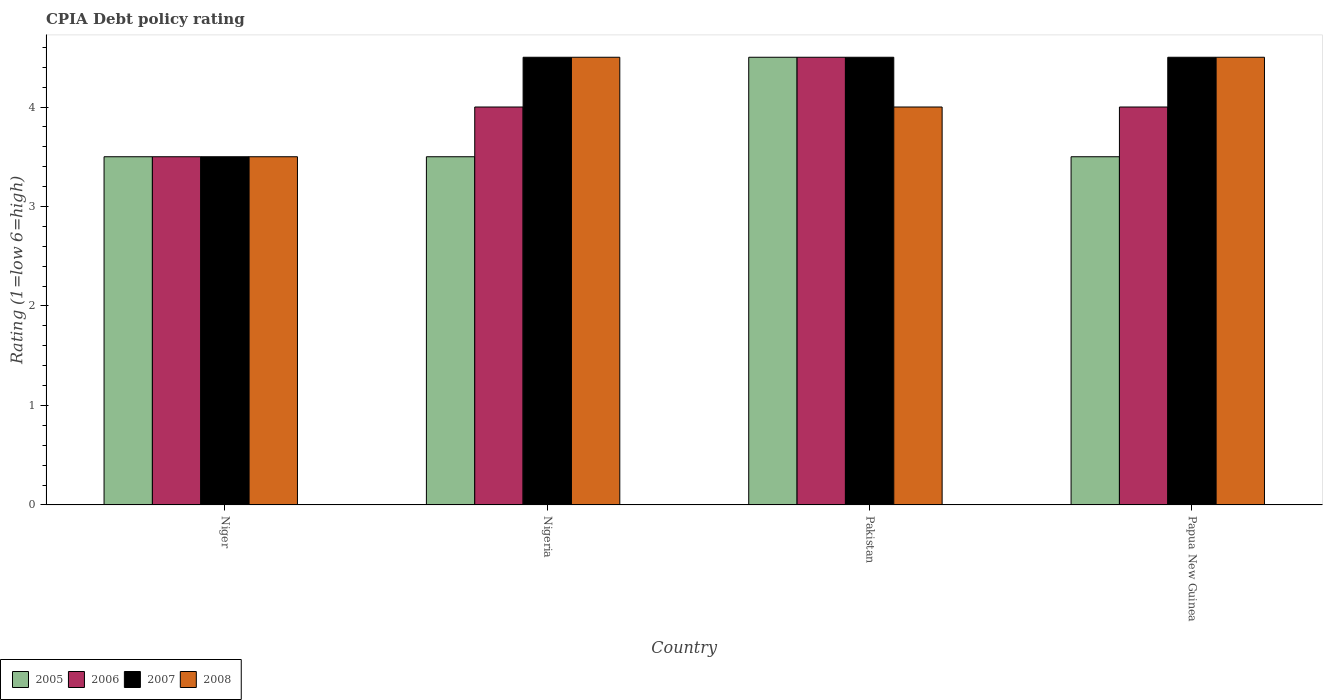How many different coloured bars are there?
Offer a terse response. 4. How many bars are there on the 1st tick from the left?
Ensure brevity in your answer.  4. What is the label of the 2nd group of bars from the left?
Offer a very short reply. Nigeria. Across all countries, what is the minimum CPIA rating in 2007?
Give a very brief answer. 3.5. In which country was the CPIA rating in 2008 maximum?
Your answer should be compact. Nigeria. In which country was the CPIA rating in 2008 minimum?
Your response must be concise. Niger. What is the total CPIA rating in 2006 in the graph?
Provide a short and direct response. 16. What is the difference between the CPIA rating of/in 2007 and CPIA rating of/in 2005 in Pakistan?
Your answer should be very brief. 0. In how many countries, is the CPIA rating in 2005 greater than 2.8?
Your response must be concise. 4. What is the ratio of the CPIA rating in 2005 in Nigeria to that in Pakistan?
Your answer should be compact. 0.78. What is the difference between the highest and the second highest CPIA rating in 2008?
Provide a short and direct response. 0.5. What is the difference between the highest and the lowest CPIA rating in 2005?
Keep it short and to the point. 1. Is the sum of the CPIA rating in 2005 in Niger and Papua New Guinea greater than the maximum CPIA rating in 2007 across all countries?
Your answer should be very brief. Yes. Is it the case that in every country, the sum of the CPIA rating in 2008 and CPIA rating in 2007 is greater than the sum of CPIA rating in 2005 and CPIA rating in 2006?
Keep it short and to the point. No. What does the 4th bar from the left in Nigeria represents?
Your answer should be very brief. 2008. How many bars are there?
Offer a terse response. 16. Are the values on the major ticks of Y-axis written in scientific E-notation?
Make the answer very short. No. Does the graph contain any zero values?
Your response must be concise. No. Does the graph contain grids?
Provide a short and direct response. No. How are the legend labels stacked?
Make the answer very short. Horizontal. What is the title of the graph?
Offer a terse response. CPIA Debt policy rating. Does "1970" appear as one of the legend labels in the graph?
Provide a short and direct response. No. What is the label or title of the X-axis?
Offer a very short reply. Country. What is the label or title of the Y-axis?
Offer a very short reply. Rating (1=low 6=high). What is the Rating (1=low 6=high) in 2005 in Niger?
Ensure brevity in your answer.  3.5. What is the Rating (1=low 6=high) of 2006 in Niger?
Your answer should be very brief. 3.5. What is the Rating (1=low 6=high) of 2005 in Nigeria?
Offer a very short reply. 3.5. What is the Rating (1=low 6=high) in 2006 in Nigeria?
Keep it short and to the point. 4. What is the Rating (1=low 6=high) in 2007 in Nigeria?
Your answer should be compact. 4.5. What is the Rating (1=low 6=high) of 2008 in Nigeria?
Your response must be concise. 4.5. What is the Rating (1=low 6=high) of 2006 in Pakistan?
Make the answer very short. 4.5. What is the Rating (1=low 6=high) in 2007 in Pakistan?
Make the answer very short. 4.5. What is the Rating (1=low 6=high) in 2005 in Papua New Guinea?
Your answer should be very brief. 3.5. What is the Rating (1=low 6=high) in 2007 in Papua New Guinea?
Give a very brief answer. 4.5. Across all countries, what is the minimum Rating (1=low 6=high) of 2007?
Ensure brevity in your answer.  3.5. Across all countries, what is the minimum Rating (1=low 6=high) of 2008?
Offer a terse response. 3.5. What is the total Rating (1=low 6=high) of 2005 in the graph?
Provide a succinct answer. 15. What is the total Rating (1=low 6=high) in 2006 in the graph?
Provide a short and direct response. 16. What is the difference between the Rating (1=low 6=high) in 2007 in Niger and that in Nigeria?
Your answer should be compact. -1. What is the difference between the Rating (1=low 6=high) in 2008 in Niger and that in Nigeria?
Make the answer very short. -1. What is the difference between the Rating (1=low 6=high) in 2006 in Niger and that in Pakistan?
Provide a short and direct response. -1. What is the difference between the Rating (1=low 6=high) of 2008 in Niger and that in Pakistan?
Provide a short and direct response. -0.5. What is the difference between the Rating (1=low 6=high) of 2006 in Niger and that in Papua New Guinea?
Offer a terse response. -0.5. What is the difference between the Rating (1=low 6=high) of 2007 in Niger and that in Papua New Guinea?
Your answer should be very brief. -1. What is the difference between the Rating (1=low 6=high) in 2005 in Nigeria and that in Pakistan?
Keep it short and to the point. -1. What is the difference between the Rating (1=low 6=high) in 2006 in Nigeria and that in Pakistan?
Make the answer very short. -0.5. What is the difference between the Rating (1=low 6=high) of 2007 in Nigeria and that in Pakistan?
Provide a succinct answer. 0. What is the difference between the Rating (1=low 6=high) of 2005 in Nigeria and that in Papua New Guinea?
Give a very brief answer. 0. What is the difference between the Rating (1=low 6=high) in 2006 in Nigeria and that in Papua New Guinea?
Ensure brevity in your answer.  0. What is the difference between the Rating (1=low 6=high) of 2005 in Pakistan and that in Papua New Guinea?
Provide a short and direct response. 1. What is the difference between the Rating (1=low 6=high) in 2006 in Pakistan and that in Papua New Guinea?
Your answer should be compact. 0.5. What is the difference between the Rating (1=low 6=high) in 2008 in Pakistan and that in Papua New Guinea?
Provide a succinct answer. -0.5. What is the difference between the Rating (1=low 6=high) of 2005 in Niger and the Rating (1=low 6=high) of 2008 in Nigeria?
Your response must be concise. -1. What is the difference between the Rating (1=low 6=high) of 2006 in Niger and the Rating (1=low 6=high) of 2007 in Nigeria?
Your response must be concise. -1. What is the difference between the Rating (1=low 6=high) of 2007 in Niger and the Rating (1=low 6=high) of 2008 in Nigeria?
Make the answer very short. -1. What is the difference between the Rating (1=low 6=high) of 2005 in Niger and the Rating (1=low 6=high) of 2006 in Pakistan?
Your response must be concise. -1. What is the difference between the Rating (1=low 6=high) in 2005 in Niger and the Rating (1=low 6=high) in 2008 in Pakistan?
Your answer should be compact. -0.5. What is the difference between the Rating (1=low 6=high) in 2006 in Niger and the Rating (1=low 6=high) in 2007 in Pakistan?
Your answer should be compact. -1. What is the difference between the Rating (1=low 6=high) in 2007 in Niger and the Rating (1=low 6=high) in 2008 in Pakistan?
Keep it short and to the point. -0.5. What is the difference between the Rating (1=low 6=high) in 2005 in Niger and the Rating (1=low 6=high) in 2007 in Papua New Guinea?
Your response must be concise. -1. What is the difference between the Rating (1=low 6=high) in 2005 in Niger and the Rating (1=low 6=high) in 2008 in Papua New Guinea?
Give a very brief answer. -1. What is the difference between the Rating (1=low 6=high) of 2006 in Niger and the Rating (1=low 6=high) of 2007 in Papua New Guinea?
Your answer should be very brief. -1. What is the difference between the Rating (1=low 6=high) in 2006 in Niger and the Rating (1=low 6=high) in 2008 in Papua New Guinea?
Offer a terse response. -1. What is the difference between the Rating (1=low 6=high) of 2005 in Nigeria and the Rating (1=low 6=high) of 2007 in Pakistan?
Offer a very short reply. -1. What is the difference between the Rating (1=low 6=high) in 2006 in Nigeria and the Rating (1=low 6=high) in 2008 in Pakistan?
Offer a very short reply. 0. What is the difference between the Rating (1=low 6=high) of 2007 in Nigeria and the Rating (1=low 6=high) of 2008 in Pakistan?
Your response must be concise. 0.5. What is the difference between the Rating (1=low 6=high) in 2005 in Nigeria and the Rating (1=low 6=high) in 2007 in Papua New Guinea?
Offer a terse response. -1. What is the difference between the Rating (1=low 6=high) of 2006 in Nigeria and the Rating (1=low 6=high) of 2007 in Papua New Guinea?
Give a very brief answer. -0.5. What is the difference between the Rating (1=low 6=high) in 2006 in Nigeria and the Rating (1=low 6=high) in 2008 in Papua New Guinea?
Make the answer very short. -0.5. What is the difference between the Rating (1=low 6=high) in 2007 in Nigeria and the Rating (1=low 6=high) in 2008 in Papua New Guinea?
Your response must be concise. 0. What is the difference between the Rating (1=low 6=high) of 2005 in Pakistan and the Rating (1=low 6=high) of 2007 in Papua New Guinea?
Your answer should be very brief. 0. What is the difference between the Rating (1=low 6=high) in 2005 in Pakistan and the Rating (1=low 6=high) in 2008 in Papua New Guinea?
Provide a succinct answer. 0. What is the average Rating (1=low 6=high) in 2005 per country?
Give a very brief answer. 3.75. What is the average Rating (1=low 6=high) in 2006 per country?
Give a very brief answer. 4. What is the average Rating (1=low 6=high) of 2007 per country?
Provide a succinct answer. 4.25. What is the average Rating (1=low 6=high) of 2008 per country?
Provide a short and direct response. 4.12. What is the difference between the Rating (1=low 6=high) of 2005 and Rating (1=low 6=high) of 2006 in Niger?
Provide a short and direct response. 0. What is the difference between the Rating (1=low 6=high) in 2006 and Rating (1=low 6=high) in 2007 in Niger?
Provide a succinct answer. 0. What is the difference between the Rating (1=low 6=high) in 2006 and Rating (1=low 6=high) in 2008 in Niger?
Your answer should be very brief. 0. What is the difference between the Rating (1=low 6=high) in 2005 and Rating (1=low 6=high) in 2006 in Nigeria?
Offer a terse response. -0.5. What is the difference between the Rating (1=low 6=high) of 2005 and Rating (1=low 6=high) of 2008 in Nigeria?
Offer a terse response. -1. What is the difference between the Rating (1=low 6=high) of 2006 and Rating (1=low 6=high) of 2008 in Nigeria?
Give a very brief answer. -0.5. What is the difference between the Rating (1=low 6=high) of 2007 and Rating (1=low 6=high) of 2008 in Pakistan?
Offer a very short reply. 0.5. What is the difference between the Rating (1=low 6=high) of 2005 and Rating (1=low 6=high) of 2008 in Papua New Guinea?
Offer a terse response. -1. What is the ratio of the Rating (1=low 6=high) of 2006 in Niger to that in Nigeria?
Provide a short and direct response. 0.88. What is the ratio of the Rating (1=low 6=high) in 2008 in Niger to that in Nigeria?
Your response must be concise. 0.78. What is the ratio of the Rating (1=low 6=high) of 2005 in Niger to that in Pakistan?
Provide a succinct answer. 0.78. What is the ratio of the Rating (1=low 6=high) of 2006 in Niger to that in Pakistan?
Keep it short and to the point. 0.78. What is the ratio of the Rating (1=low 6=high) in 2006 in Niger to that in Papua New Guinea?
Your response must be concise. 0.88. What is the ratio of the Rating (1=low 6=high) in 2007 in Niger to that in Papua New Guinea?
Your response must be concise. 0.78. What is the ratio of the Rating (1=low 6=high) in 2005 in Nigeria to that in Pakistan?
Provide a succinct answer. 0.78. What is the ratio of the Rating (1=low 6=high) of 2008 in Nigeria to that in Pakistan?
Your response must be concise. 1.12. What is the ratio of the Rating (1=low 6=high) in 2005 in Nigeria to that in Papua New Guinea?
Give a very brief answer. 1. What is the ratio of the Rating (1=low 6=high) of 2006 in Nigeria to that in Papua New Guinea?
Provide a succinct answer. 1. What is the ratio of the Rating (1=low 6=high) in 2008 in Nigeria to that in Papua New Guinea?
Your answer should be very brief. 1. What is the ratio of the Rating (1=low 6=high) of 2005 in Pakistan to that in Papua New Guinea?
Keep it short and to the point. 1.29. What is the ratio of the Rating (1=low 6=high) of 2007 in Pakistan to that in Papua New Guinea?
Offer a terse response. 1. What is the ratio of the Rating (1=low 6=high) of 2008 in Pakistan to that in Papua New Guinea?
Give a very brief answer. 0.89. What is the difference between the highest and the second highest Rating (1=low 6=high) in 2005?
Provide a short and direct response. 1. What is the difference between the highest and the second highest Rating (1=low 6=high) of 2007?
Give a very brief answer. 0. What is the difference between the highest and the second highest Rating (1=low 6=high) in 2008?
Provide a short and direct response. 0. What is the difference between the highest and the lowest Rating (1=low 6=high) of 2005?
Offer a terse response. 1. What is the difference between the highest and the lowest Rating (1=low 6=high) in 2006?
Provide a succinct answer. 1. What is the difference between the highest and the lowest Rating (1=low 6=high) of 2007?
Offer a terse response. 1. 